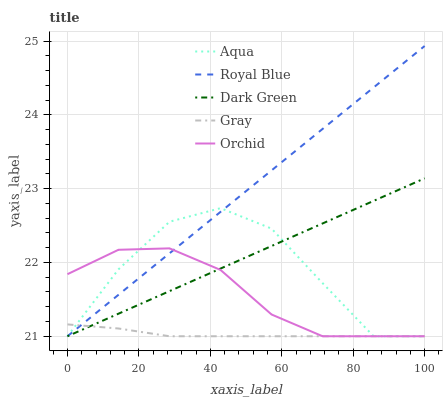Does Gray have the minimum area under the curve?
Answer yes or no. Yes. Does Royal Blue have the maximum area under the curve?
Answer yes or no. Yes. Does Orchid have the minimum area under the curve?
Answer yes or no. No. Does Orchid have the maximum area under the curve?
Answer yes or no. No. Is Dark Green the smoothest?
Answer yes or no. Yes. Is Aqua the roughest?
Answer yes or no. Yes. Is Gray the smoothest?
Answer yes or no. No. Is Gray the roughest?
Answer yes or no. No. Does Royal Blue have the lowest value?
Answer yes or no. Yes. Does Royal Blue have the highest value?
Answer yes or no. Yes. Does Orchid have the highest value?
Answer yes or no. No. Does Aqua intersect Orchid?
Answer yes or no. Yes. Is Aqua less than Orchid?
Answer yes or no. No. Is Aqua greater than Orchid?
Answer yes or no. No. 